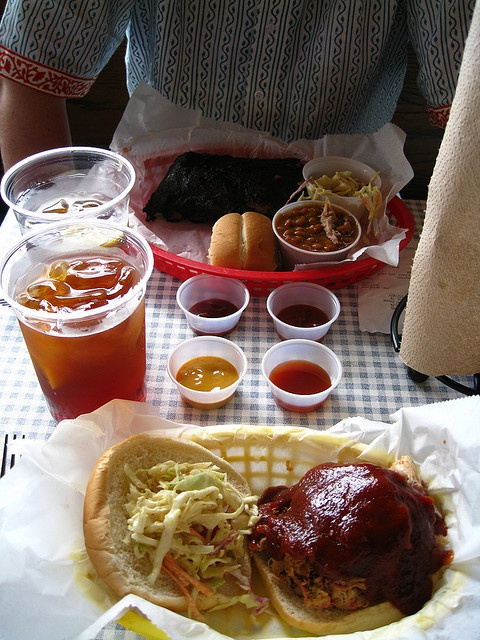Describe the objects in this image and their specific colors. I can see people in black, maroon, and gray tones, sandwich in black, maroon, and olive tones, sandwich in black, olive, tan, and maroon tones, dining table in black, white, darkgray, and gray tones, and cup in black, white, maroon, and brown tones in this image. 